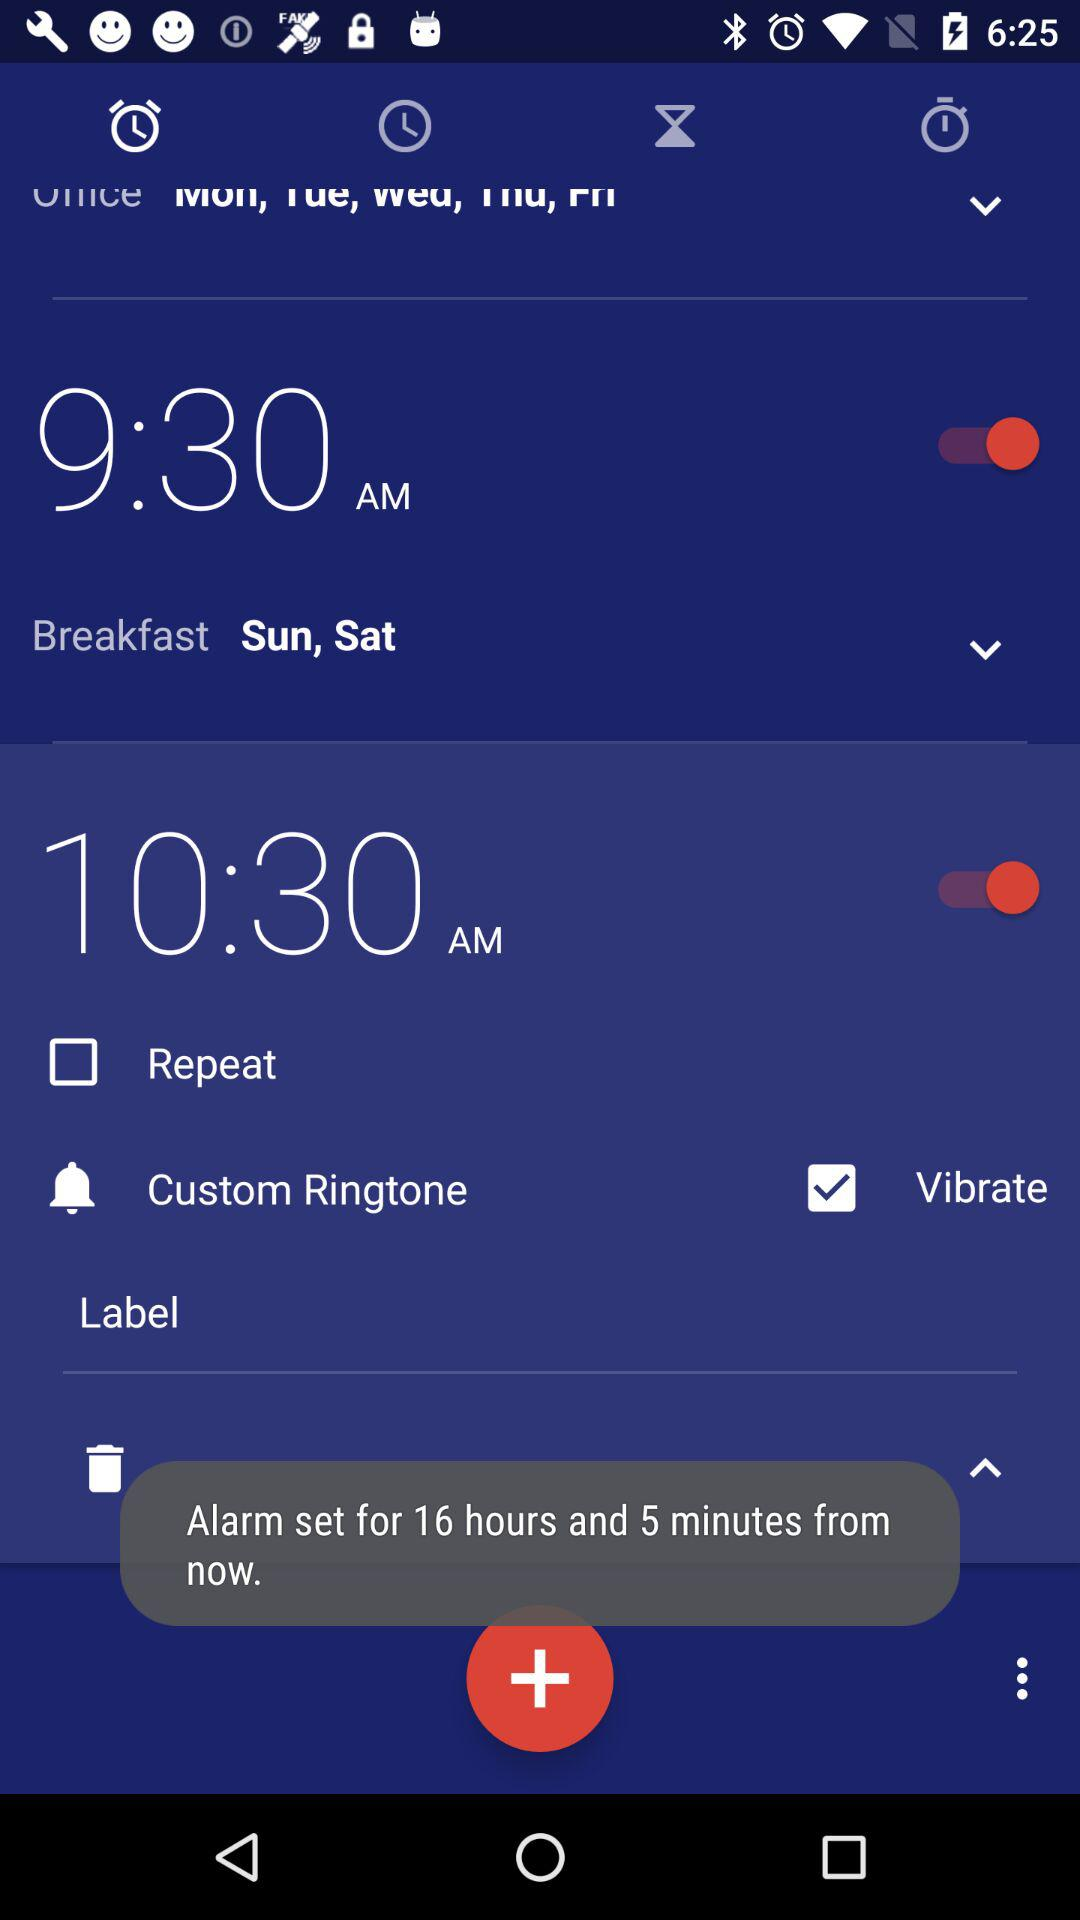Which ringtone is selected?
When the provided information is insufficient, respond with <no answer>. <no answer> 